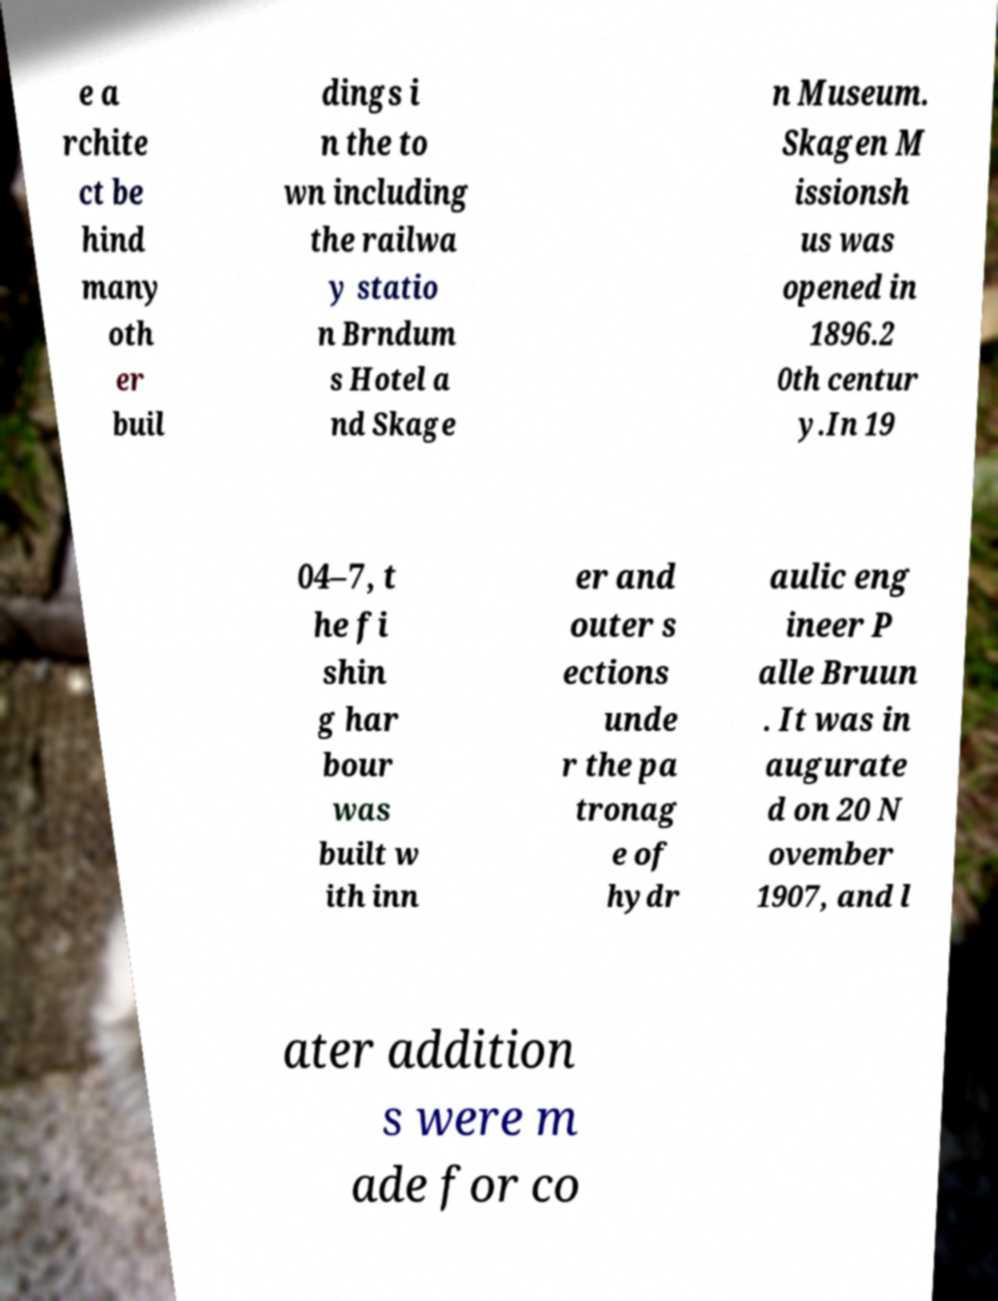Could you assist in decoding the text presented in this image and type it out clearly? e a rchite ct be hind many oth er buil dings i n the to wn including the railwa y statio n Brndum s Hotel a nd Skage n Museum. Skagen M issionsh us was opened in 1896.2 0th centur y.In 19 04–7, t he fi shin g har bour was built w ith inn er and outer s ections unde r the pa tronag e of hydr aulic eng ineer P alle Bruun . It was in augurate d on 20 N ovember 1907, and l ater addition s were m ade for co 